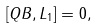<formula> <loc_0><loc_0><loc_500><loc_500>[ Q B , L _ { 1 } ] = 0 ,</formula> 